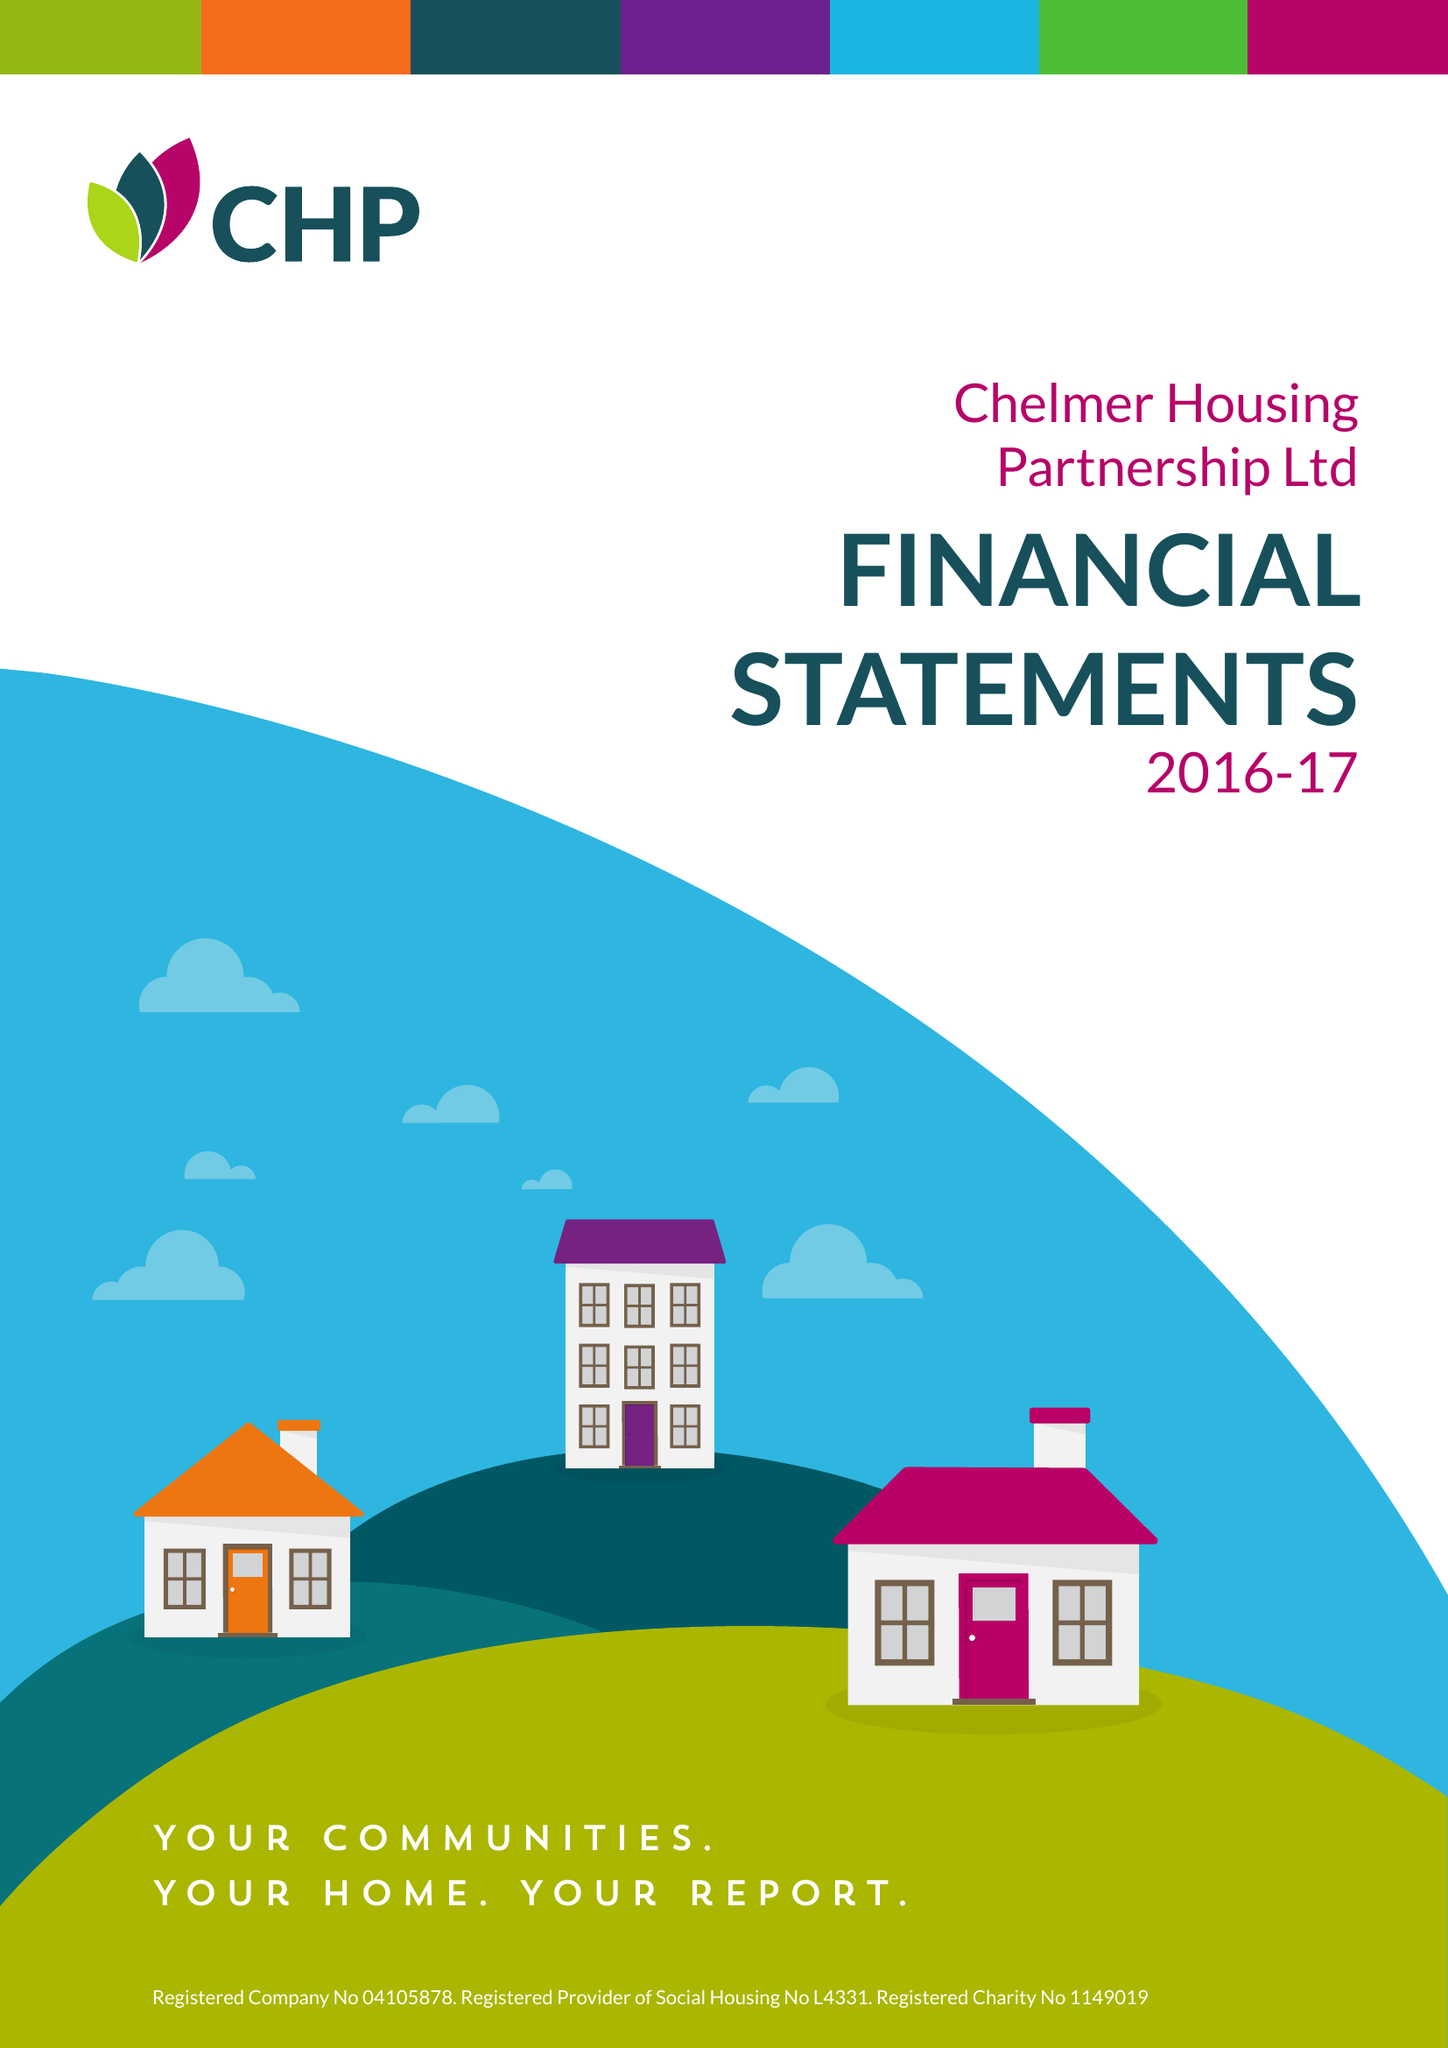What is the value for the address__street_line?
Answer the question using a single word or phrase. None 